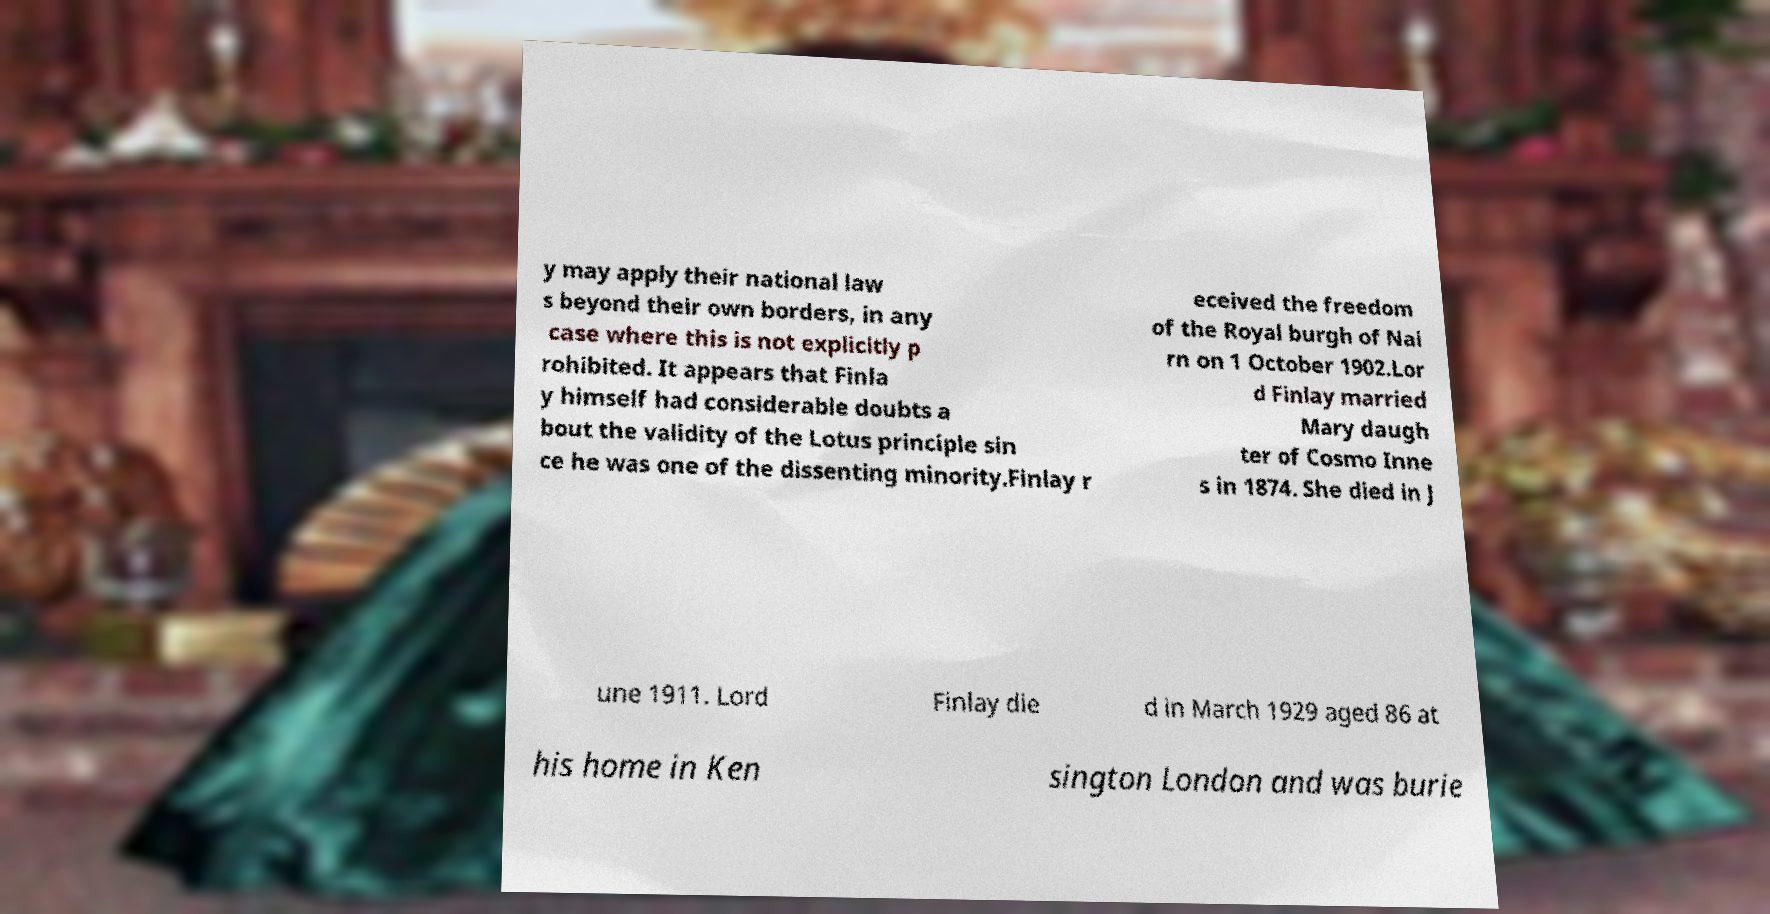Please read and relay the text visible in this image. What does it say? y may apply their national law s beyond their own borders, in any case where this is not explicitly p rohibited. It appears that Finla y himself had considerable doubts a bout the validity of the Lotus principle sin ce he was one of the dissenting minority.Finlay r eceived the freedom of the Royal burgh of Nai rn on 1 October 1902.Lor d Finlay married Mary daugh ter of Cosmo Inne s in 1874. She died in J une 1911. Lord Finlay die d in March 1929 aged 86 at his home in Ken sington London and was burie 